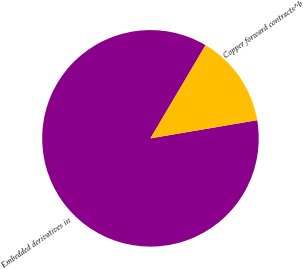Convert chart. <chart><loc_0><loc_0><loc_500><loc_500><pie_chart><fcel>Embedded derivatives in<fcel>Copper forward contracts^b<nl><fcel>86.18%<fcel>13.82%<nl></chart> 